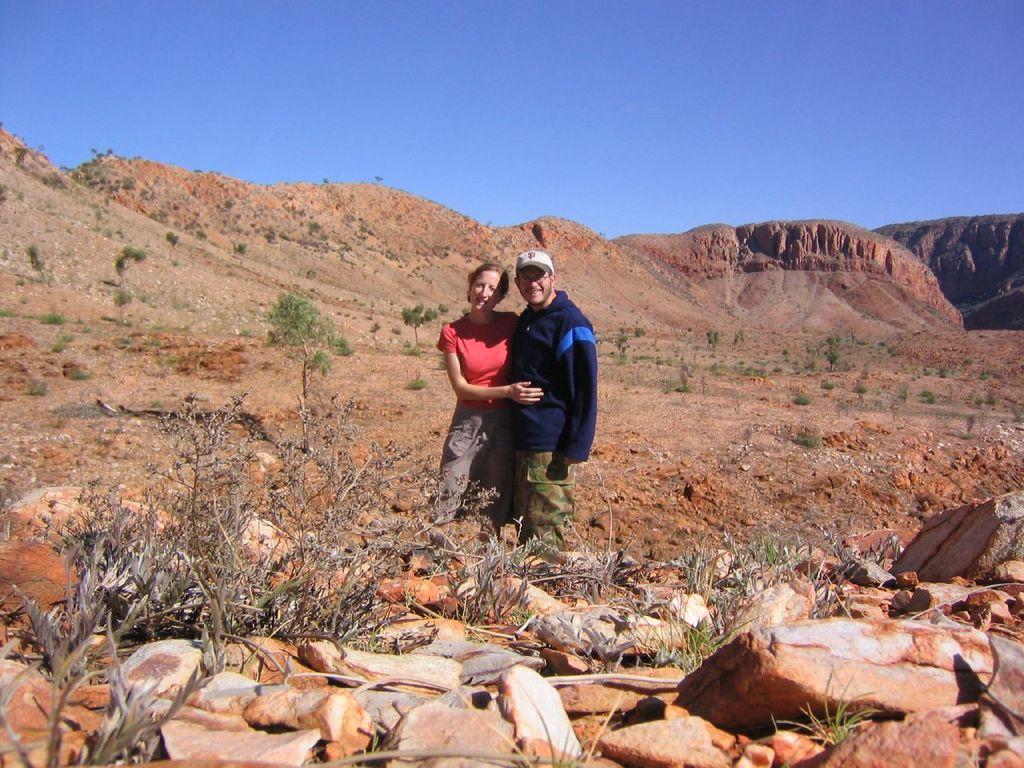Describe this image in one or two sentences. In the foreground of this image, there is a man in blue T shirt and a woman in red T shirt and a brown pant. On bottom, we see few stones and plants on the ground and on top, we see plants, trees mountains and the sky. 